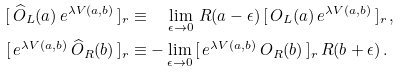Convert formula to latex. <formula><loc_0><loc_0><loc_500><loc_500>[ \, \widehat { O } _ { L } ( a ) \, e ^ { \lambda V ( a , b ) } \, ] _ { r } & \equiv \quad \lim _ { \epsilon \to 0 } \, R ( a - \epsilon ) \, [ \, O _ { L } ( a ) \, e ^ { \lambda V ( a , b ) } \, ] _ { r } \, , \\ [ \, e ^ { \lambda V ( a , b ) } \, \widehat { O } _ { R } ( b ) \, ] _ { r } & \equiv - \lim _ { \epsilon \to 0 } \, [ \, e ^ { \lambda V ( a , b ) } \, O _ { R } ( b ) \, ] _ { r } \, R ( b + \epsilon ) \, .</formula> 